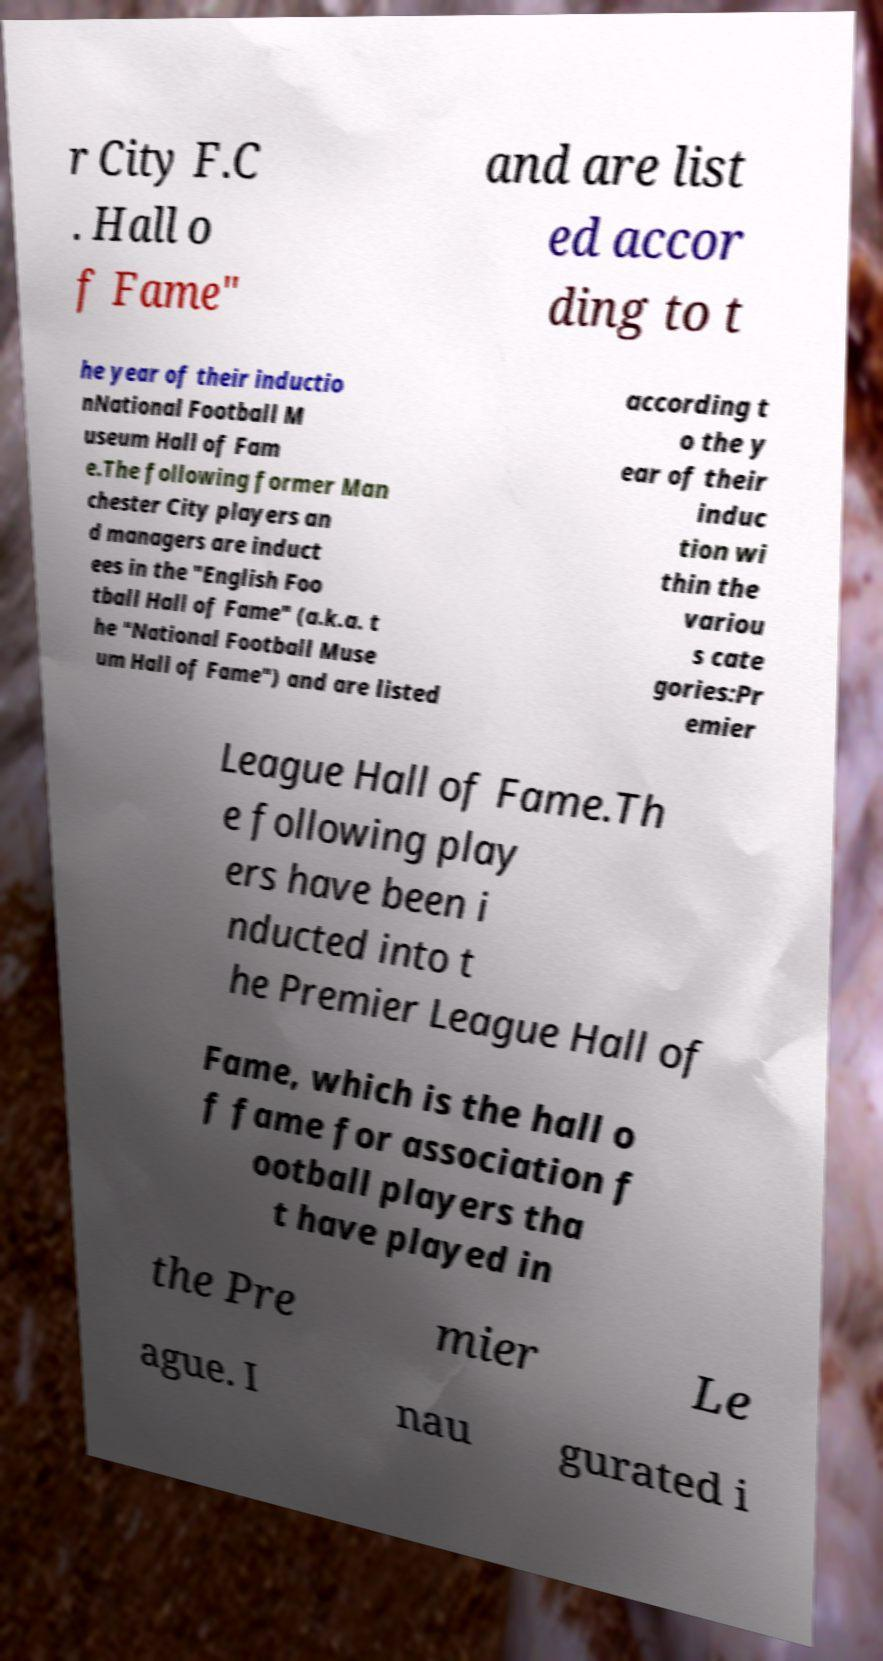There's text embedded in this image that I need extracted. Can you transcribe it verbatim? r City F.C . Hall o f Fame" and are list ed accor ding to t he year of their inductio nNational Football M useum Hall of Fam e.The following former Man chester City players an d managers are induct ees in the "English Foo tball Hall of Fame" (a.k.a. t he "National Football Muse um Hall of Fame") and are listed according t o the y ear of their induc tion wi thin the variou s cate gories:Pr emier League Hall of Fame.Th e following play ers have been i nducted into t he Premier League Hall of Fame, which is the hall o f fame for association f ootball players tha t have played in the Pre mier Le ague. I nau gurated i 